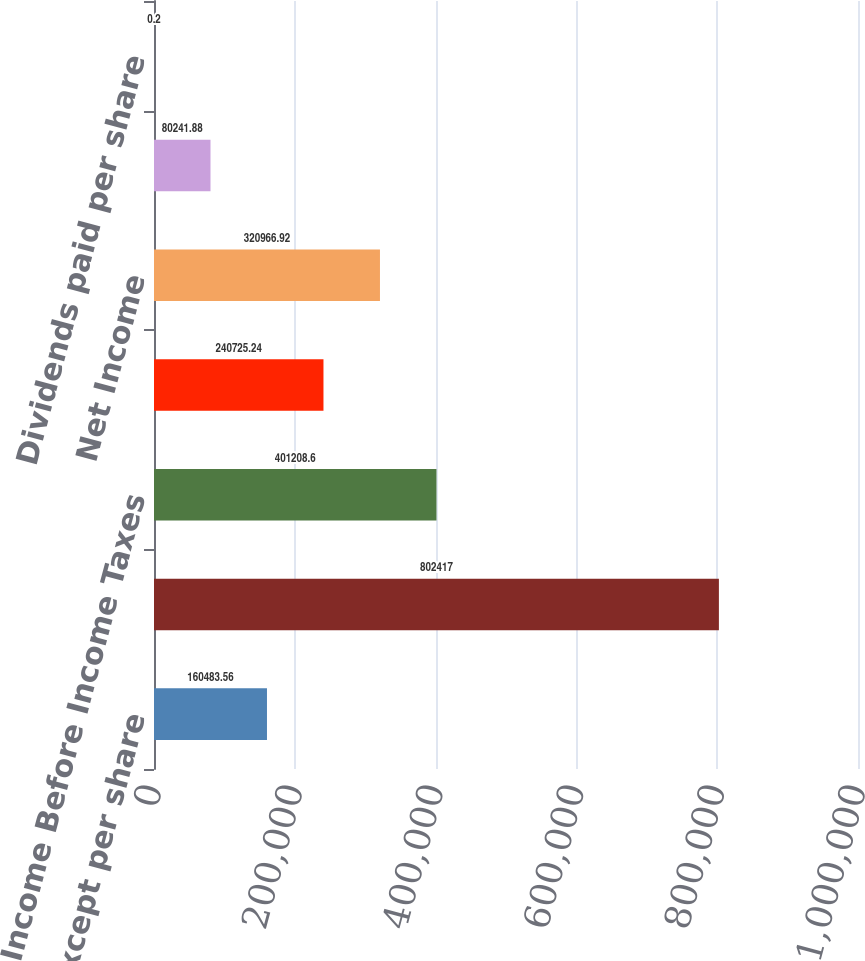Convert chart to OTSL. <chart><loc_0><loc_0><loc_500><loc_500><bar_chart><fcel>(in thousands except per share<fcel>Revenues<fcel>Income Before Income Taxes<fcel>Income before cumulative<fcel>Net Income<fcel>Income before change in<fcel>Dividends paid per share<nl><fcel>160484<fcel>802417<fcel>401209<fcel>240725<fcel>320967<fcel>80241.9<fcel>0.2<nl></chart> 